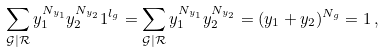<formula> <loc_0><loc_0><loc_500><loc_500>\sum _ { \mathcal { G } | \mathcal { R } } y _ { 1 } ^ { N _ { y _ { 1 } } } y _ { 2 } ^ { N _ { y _ { 2 } } } 1 ^ { l _ { g } } = \sum _ { \mathcal { G } | \mathcal { R } } y _ { 1 } ^ { N _ { y _ { 1 } } } y _ { 2 } ^ { N _ { y _ { 2 } } } = ( y _ { 1 } + y _ { 2 } ) ^ { N _ { g } } = 1 \, ,</formula> 